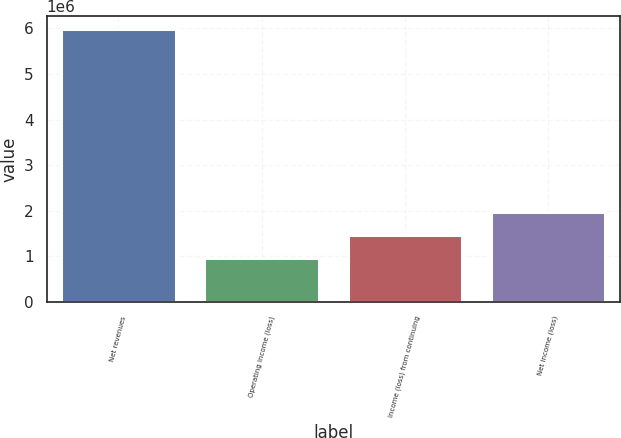<chart> <loc_0><loc_0><loc_500><loc_500><bar_chart><fcel>Net revenues<fcel>Operating income (loss)<fcel>Income (loss) from continuing<fcel>Net income (loss)<nl><fcel>5.97859e+06<fcel>963876<fcel>1.46535e+06<fcel>1.96682e+06<nl></chart> 